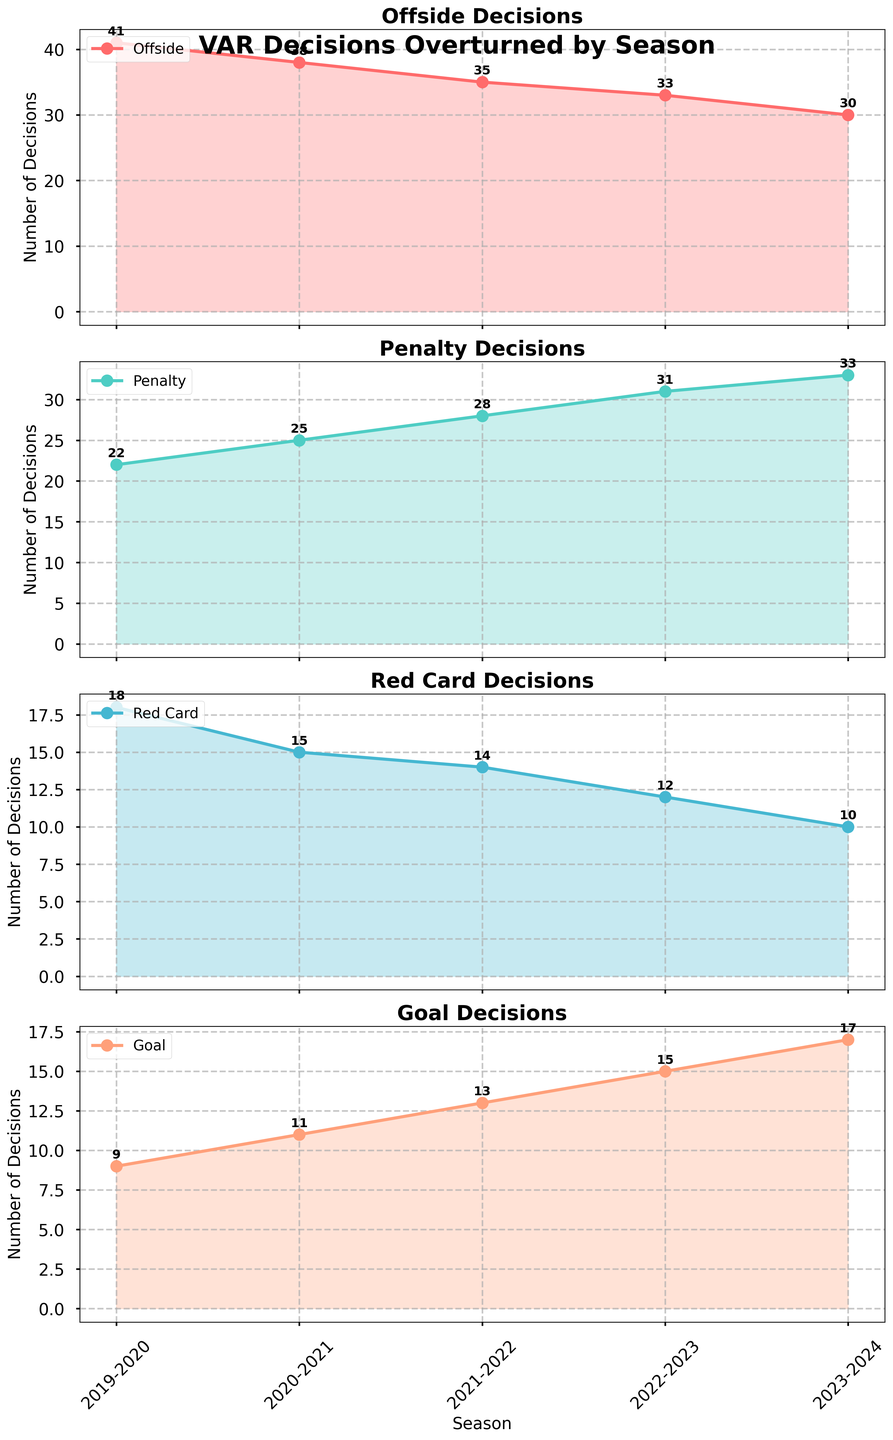What's the trend in the number of offside decisions overturned by VAR from the 2019-2020 to the 2023-2024 season? Observe the 'Offside' subplot. The number of offside decisions overturned decreases from 41 in the 2019-2020 season to 30 in the 2023-2024 season.
Answer: Decreasing Which category had the most decisions overturned in the 2023-2024 season? Look at the values for the 2023-2024 season across all subplots. The 'Penalty' category has the highest value at 33.
Answer: Penalty How many total decisions were overturned by VAR in the 2021-2022 season? Add the numbers for all categories in the 2021-2022 season: 35 (Offside) + 28 (Penalty) + 14 (Red Card) + 13 (Goal) = 90.
Answer: 90 What is the difference in the number of penalty decisions overturned between the 2019-2020 and the 2022-2023 seasons? Subtract the number of penalty decisions in the 2019-2020 season (22) from the 2022-2023 season (31): 31 - 22 = 9.
Answer: 9 How does the average number of red card decisions overturned compare between the first and last seasons? Calculate the average for the 2019-2020 and 2023-2024 seasons. 
For 2019-2020: 18. 
For 2023-2024: 10. 
The difference is 18 - 10 = 8.
Answer: The average for 2019-2020 is higher by 8 In which season did the number of goal decisions overturned increase by the largest amount from the previous season? Compare the increases in 'Goal' decisions each season.
2020-2021: 11 - 9 = 2
2021-2022: 13 - 11 = 2
2022-2023: 15 - 13 = 2
2023-2024: 17 - 15 = 2
All increases are 2, so the increases are consistent each year.
Answer: Consistent increases each year What's the average number of decisions overturned per category in the 2020-2021 season? Add the number of decisions for each category in the 2020-2021 season and divide by 4: (38 + 25 + 15 + 11) / 4 = 89 / 4 = 22.25.
Answer: 22.25 Which category shows the most stable trend over the seasons? Examine the spread and fluctuation of lines across categories. The 'Offside' category shows a consistent downward trend, indicating stability.
Answer: Offside What was the approximate percentage increase in the number of goal decisions overturned from 2019-2020 to 2023-2024? Calculate the percentage increase: ((2023-2024 value - 2019-2020 value) / 2019-2020 value) * 100.
((17 - 9) / 9) * 100 ≈ 88.89%.
Answer: 88.89% Which category had the greatest total number of decisions overturned over the entire period? Sum the numbers for each category from all seasons. Penalty: 22+25+28+31+33=139, Offside: 41+38+35+33+30=177, Red Card: 18+15+14+12+10=69, Goal: 9+11+13+15+17=65. The 'Offside' category had the highest total.
Answer: Offside 